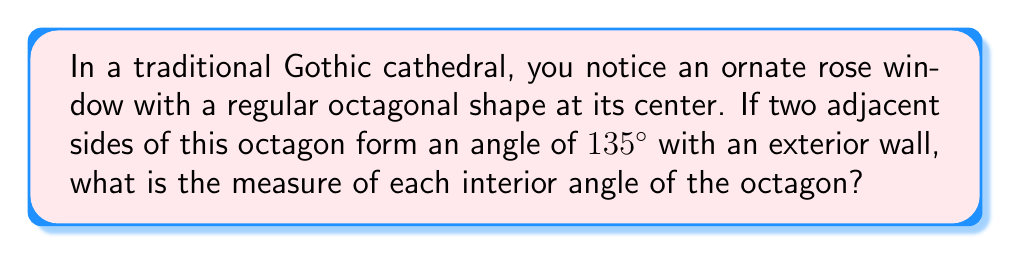Show me your answer to this math problem. Let's approach this step-by-step:

1) First, recall that the sum of interior angles of a regular polygon with $n$ sides is given by the formula:

   $S = (n-2) \times 180°$

2) For an octagon, $n = 8$, so:

   $S = (8-2) \times 180° = 6 \times 180° = 1080°$

3) In a regular polygon, all interior angles are equal. To find each angle, we divide the sum by the number of angles:

   $\text{Each interior angle} = \frac{1080°}{8} = 135°$

4) Now, let's consider the information about the exterior wall. Two adjacent sides form an angle of $135°$ with the wall. This forms a straight line, which we know is $180°$.

5) If we call the interior angle of the octagon $x$, we can write:

   $x + 135° = 180°$

6) Solving for $x$:

   $x = 180° - 135° = 45°$

7) This $45°$ is the exterior angle of the octagon. The interior and exterior angles of a polygon are supplementary, meaning they add up to $180°$.

8) Therefore, we can confirm our earlier calculation:

   $\text{Interior angle} = 180° - 45° = 135°$

This matches our result from step 3, verifying our solution.
Answer: $135°$ 